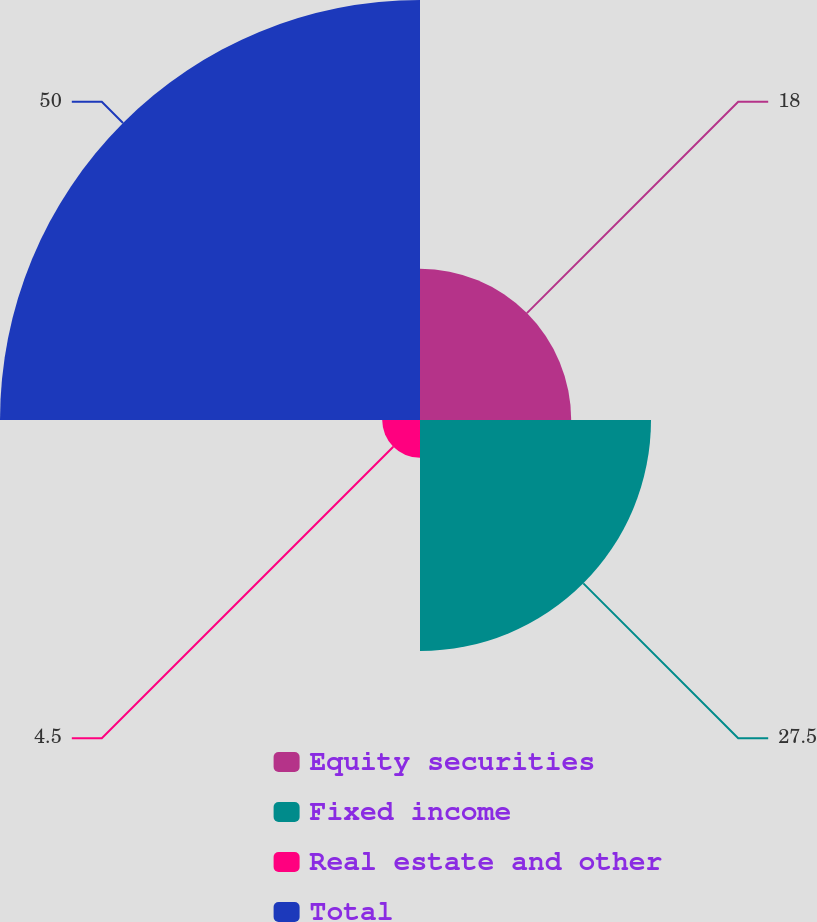<chart> <loc_0><loc_0><loc_500><loc_500><pie_chart><fcel>Equity securities<fcel>Fixed income<fcel>Real estate and other<fcel>Total<nl><fcel>18.0%<fcel>27.5%<fcel>4.5%<fcel>50.0%<nl></chart> 